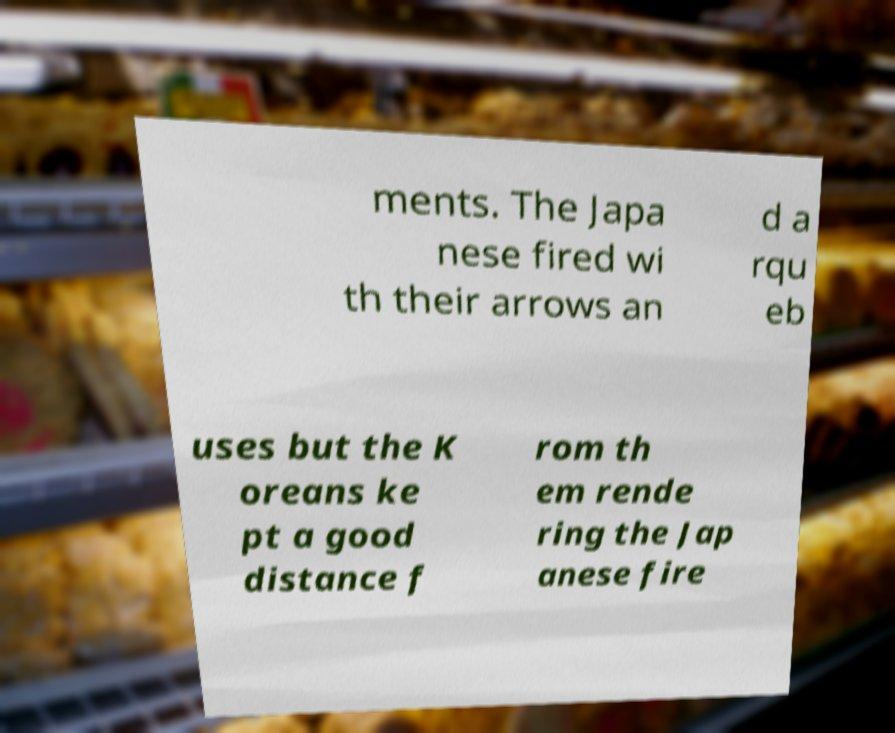Could you extract and type out the text from this image? ments. The Japa nese fired wi th their arrows an d a rqu eb uses but the K oreans ke pt a good distance f rom th em rende ring the Jap anese fire 